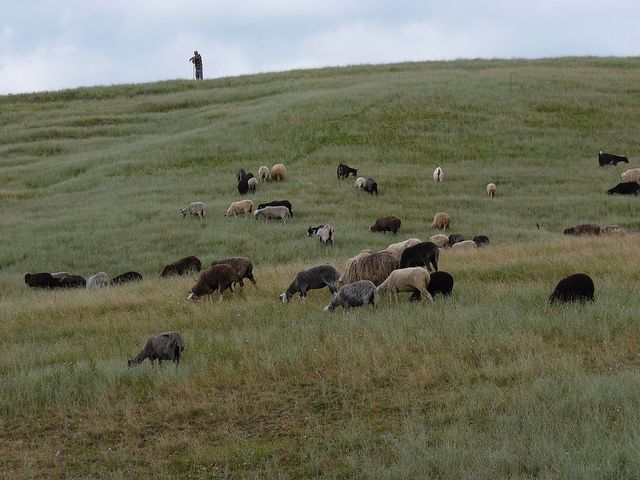<image>What breed of livestock is shown? I am not sure what breed of livestock is shown. It could be sheep, cows, or goat. What game would you play when you saw this as a child? It is ambiguous what game I would play when I saw this as a child. What breed of livestock is shown? I am not sure what breed of livestock is shown. It can be sheep, cows or goat. What game would you play when you saw this as a child? I am not sure what game you would play when you saw this as a child. It can be 'patty cake', 'frisbee', 'tag' or 'counting sheep'. 